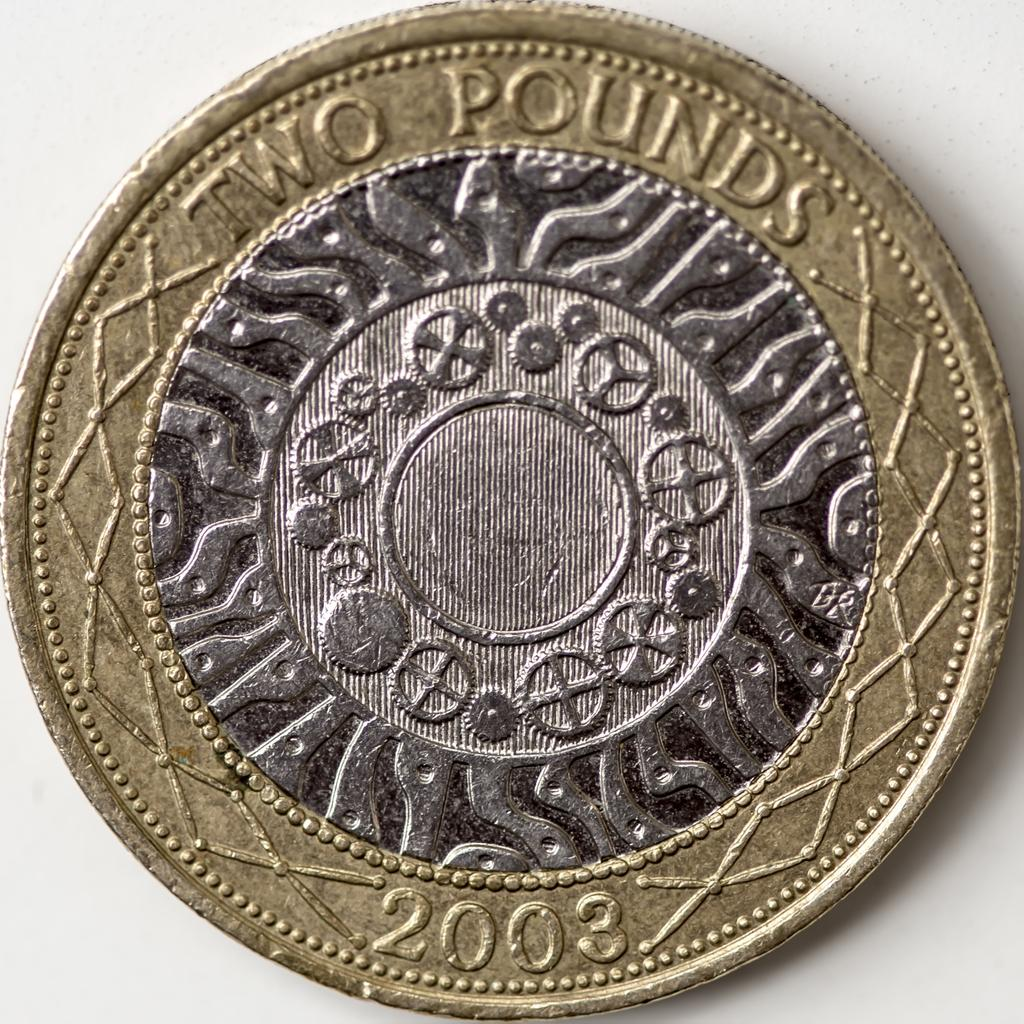<image>
Relay a brief, clear account of the picture shown. A gold and silver two pound coin from 2003. 